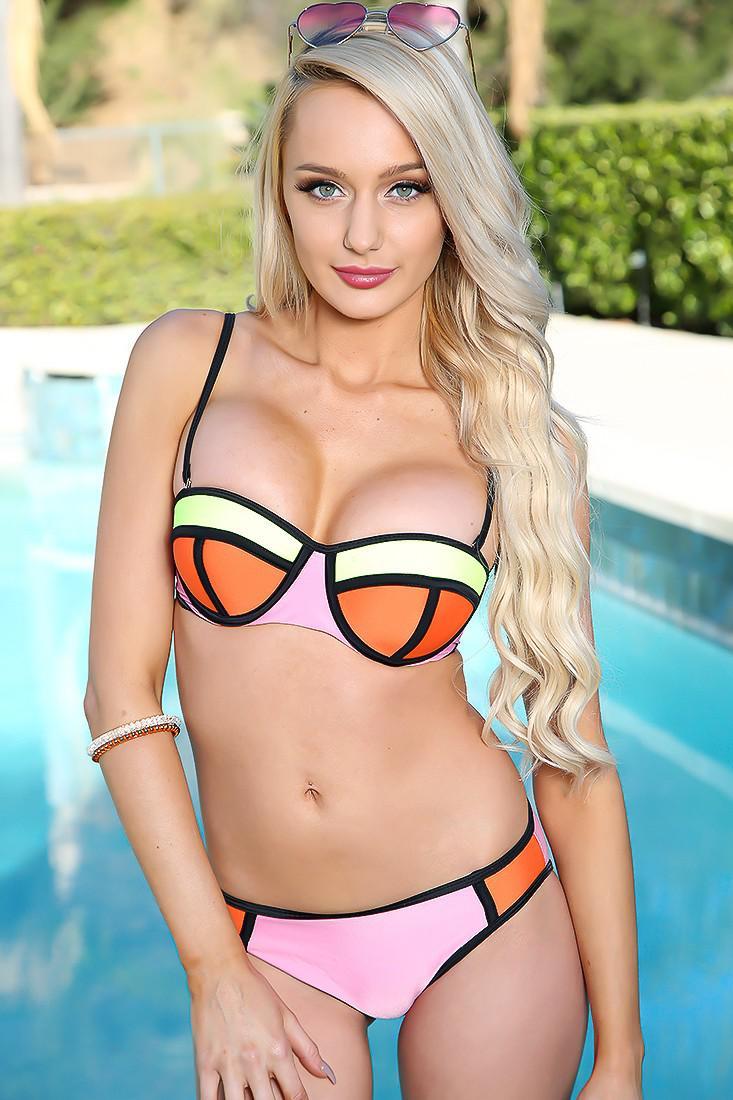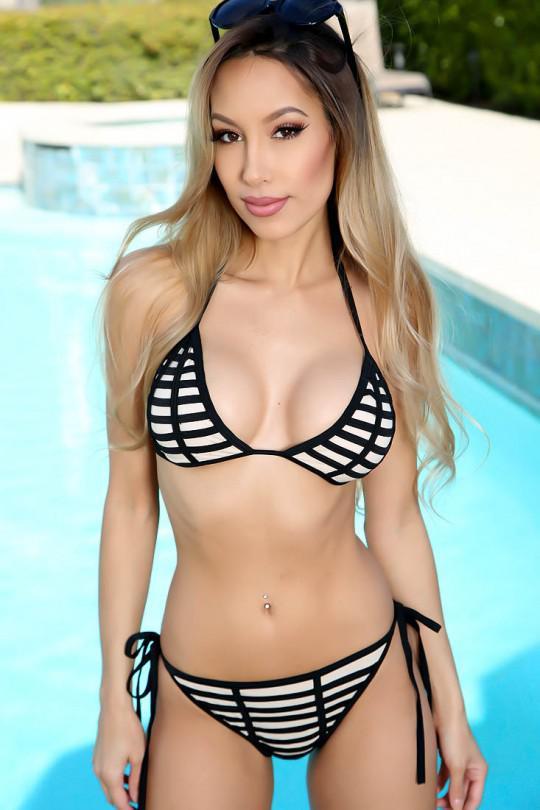The first image is the image on the left, the second image is the image on the right. Considering the images on both sides, is "At least one woman has sunglasses on her head." valid? Answer yes or no. Yes. 